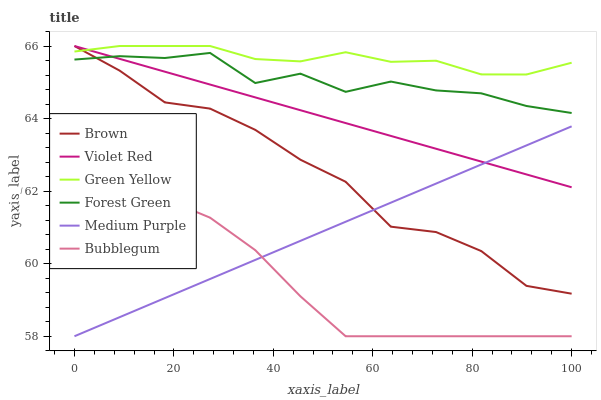Does Bubblegum have the minimum area under the curve?
Answer yes or no. Yes. Does Green Yellow have the maximum area under the curve?
Answer yes or no. Yes. Does Violet Red have the minimum area under the curve?
Answer yes or no. No. Does Violet Red have the maximum area under the curve?
Answer yes or no. No. Is Violet Red the smoothest?
Answer yes or no. Yes. Is Forest Green the roughest?
Answer yes or no. Yes. Is Bubblegum the smoothest?
Answer yes or no. No. Is Bubblegum the roughest?
Answer yes or no. No. Does Bubblegum have the lowest value?
Answer yes or no. Yes. Does Violet Red have the lowest value?
Answer yes or no. No. Does Green Yellow have the highest value?
Answer yes or no. Yes. Does Bubblegum have the highest value?
Answer yes or no. No. Is Medium Purple less than Forest Green?
Answer yes or no. Yes. Is Forest Green greater than Medium Purple?
Answer yes or no. Yes. Does Forest Green intersect Violet Red?
Answer yes or no. Yes. Is Forest Green less than Violet Red?
Answer yes or no. No. Is Forest Green greater than Violet Red?
Answer yes or no. No. Does Medium Purple intersect Forest Green?
Answer yes or no. No. 